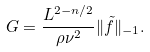<formula> <loc_0><loc_0><loc_500><loc_500>G = \frac { L ^ { 2 - n / 2 } } { \rho \nu ^ { 2 } } \| \tilde { f } \| _ { - 1 } .</formula> 